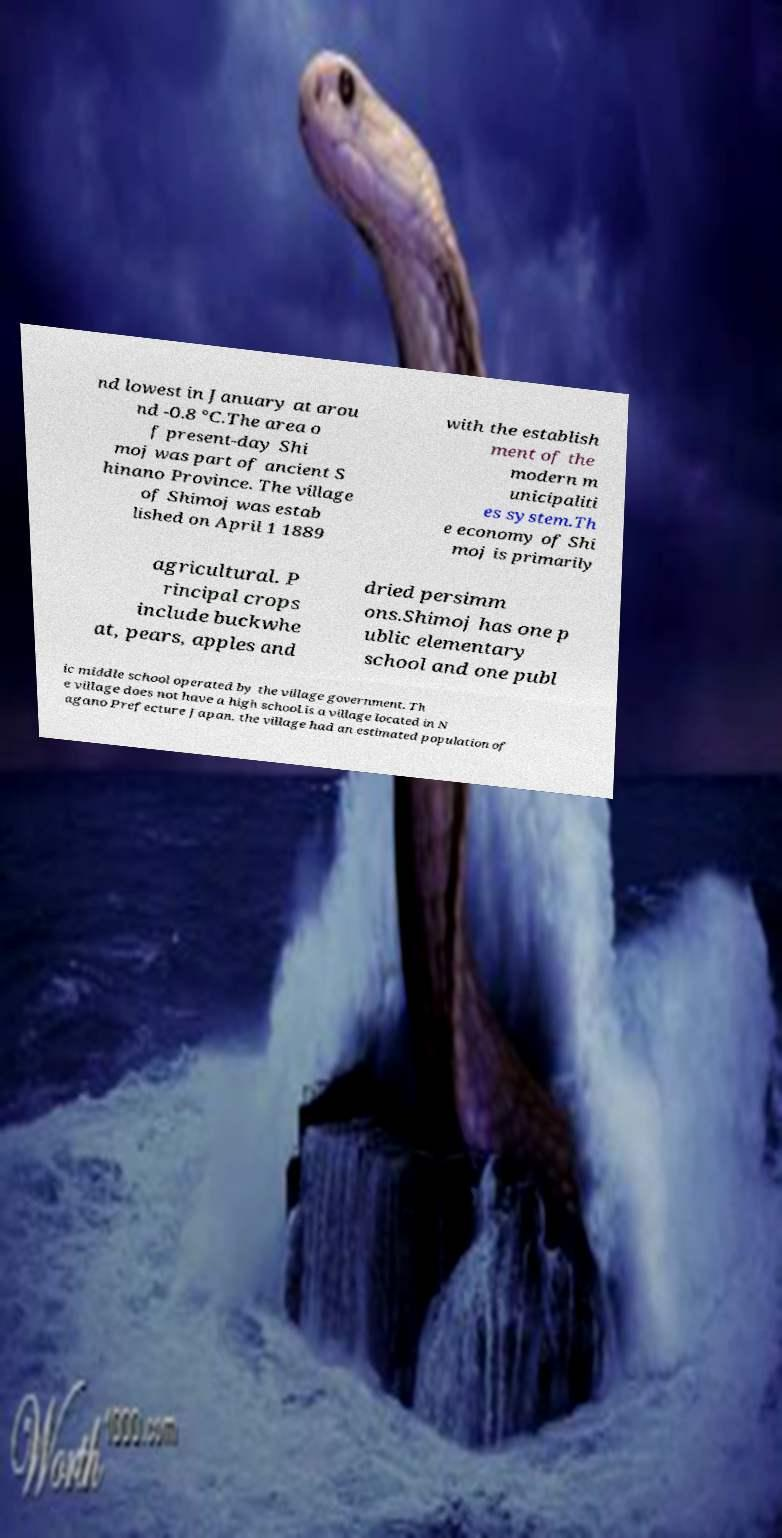Can you accurately transcribe the text from the provided image for me? nd lowest in January at arou nd -0.8 °C.The area o f present-day Shi moj was part of ancient S hinano Province. The village of Shimoj was estab lished on April 1 1889 with the establish ment of the modern m unicipaliti es system.Th e economy of Shi moj is primarily agricultural. P rincipal crops include buckwhe at, pears, apples and dried persimm ons.Shimoj has one p ublic elementary school and one publ ic middle school operated by the village government. Th e village does not have a high school.is a village located in N agano Prefecture Japan. the village had an estimated population of 